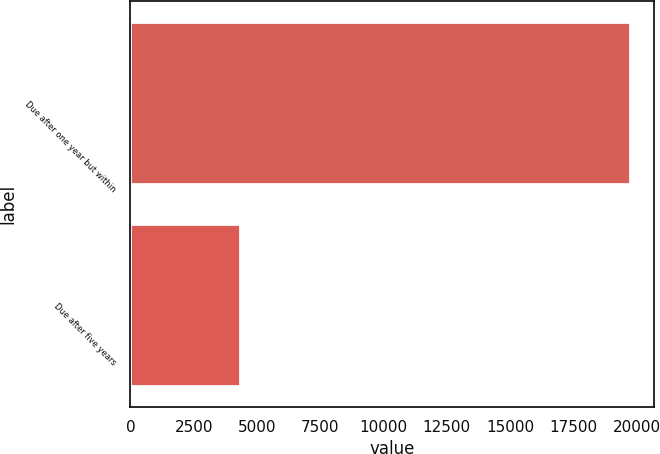Convert chart. <chart><loc_0><loc_0><loc_500><loc_500><bar_chart><fcel>Due after one year but within<fcel>Due after five years<nl><fcel>19722<fcel>4345<nl></chart> 